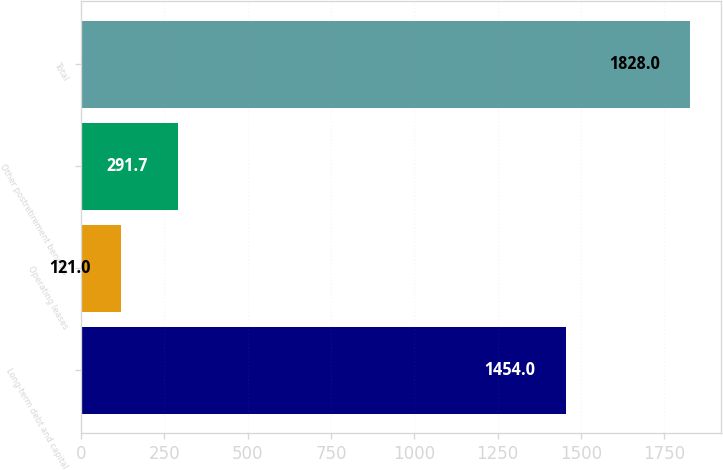<chart> <loc_0><loc_0><loc_500><loc_500><bar_chart><fcel>Long-term debt and capital<fcel>Operating leases<fcel>Other postretirement benefits<fcel>Total<nl><fcel>1454<fcel>121<fcel>291.7<fcel>1828<nl></chart> 